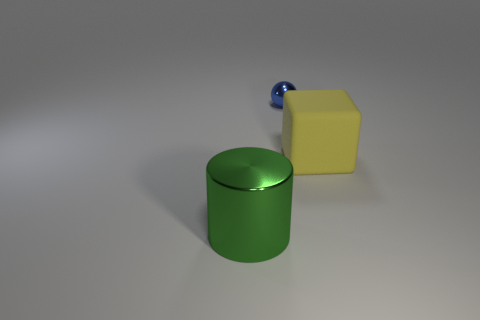There is a thing that is both behind the shiny cylinder and in front of the tiny metal ball; what shape is it?
Your answer should be very brief. Cube. Are there more big purple metal cylinders than large green shiny things?
Provide a succinct answer. No. What is the material of the small blue sphere?
Provide a short and direct response. Metal. Is there any other thing that is the same size as the blue metal sphere?
Give a very brief answer. No. Is there a blue metal sphere to the right of the large green thing in front of the yellow block?
Make the answer very short. Yes. What number of other things are the same shape as the large yellow matte object?
Offer a terse response. 0. Are there more large green cylinders left of the tiny blue sphere than large metallic things that are in front of the big rubber block?
Provide a short and direct response. No. Is the size of the metallic object in front of the tiny sphere the same as the object right of the tiny ball?
Your response must be concise. Yes. What is the shape of the rubber thing?
Offer a very short reply. Cube. The ball that is made of the same material as the green cylinder is what color?
Give a very brief answer. Blue. 